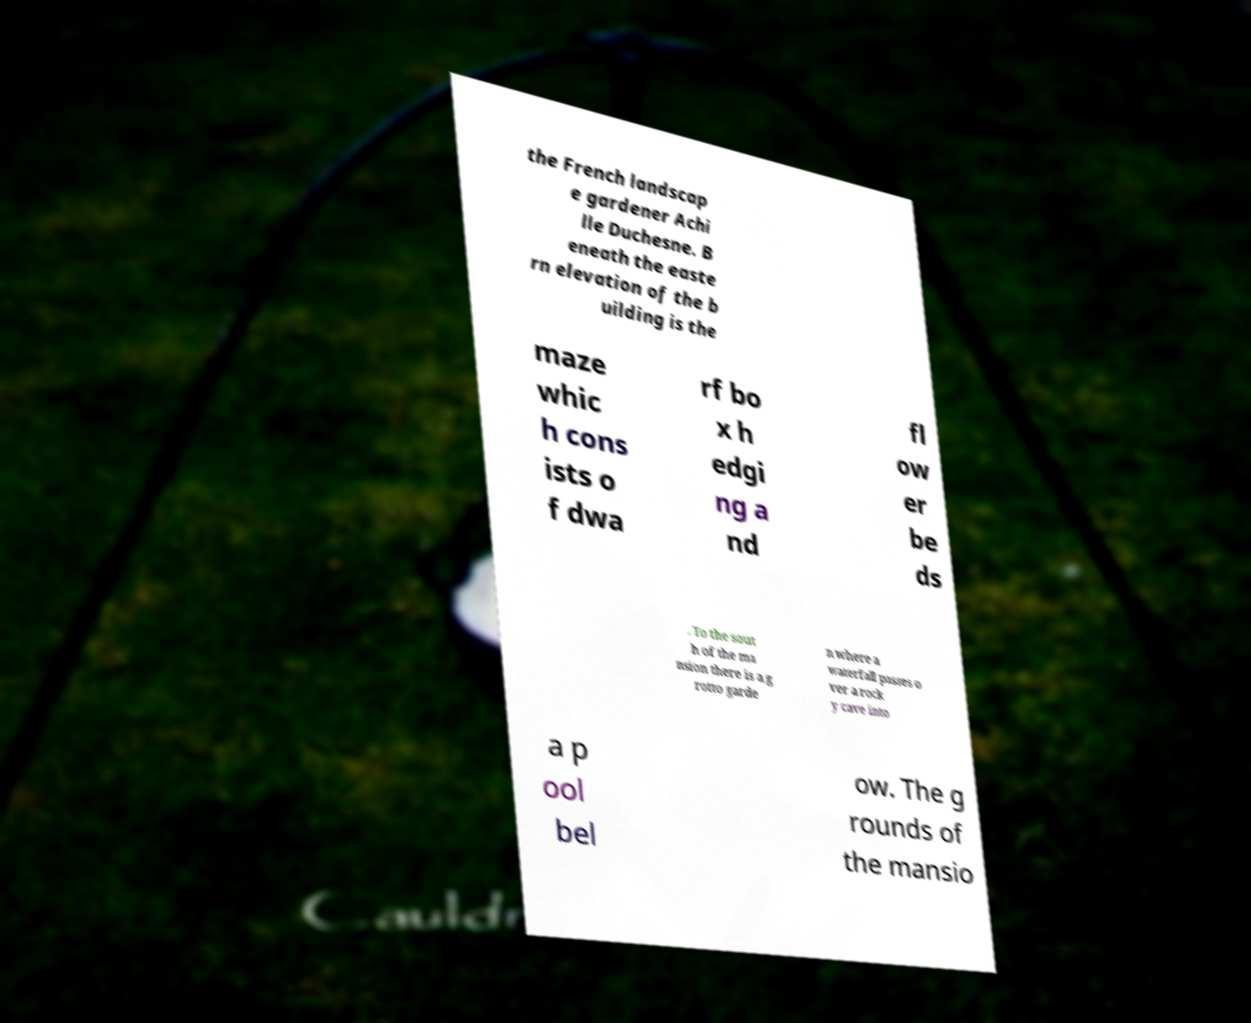What messages or text are displayed in this image? I need them in a readable, typed format. the French landscap e gardener Achi lle Duchesne. B eneath the easte rn elevation of the b uilding is the maze whic h cons ists o f dwa rf bo x h edgi ng a nd fl ow er be ds . To the sout h of the ma nsion there is a g rotto garde n where a waterfall passes o ver a rock y cave into a p ool bel ow. The g rounds of the mansio 